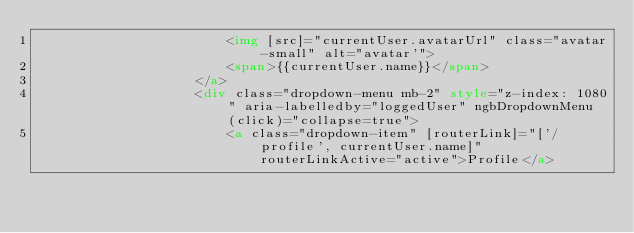Convert code to text. <code><loc_0><loc_0><loc_500><loc_500><_HTML_>                        <img [src]="currentUser.avatarUrl" class="avatar-small" alt="avatar'">
                        <span>{{currentUser.name}}</span>
                    </a>
                    <div class="dropdown-menu mb-2" style="z-index: 1080" aria-labelledby="loggedUser" ngbDropdownMenu (click)="collapse=true">
                        <a class="dropdown-item" [routerLink]="['/profile', currentUser.name]" routerLinkActive="active">Profile</a></code> 